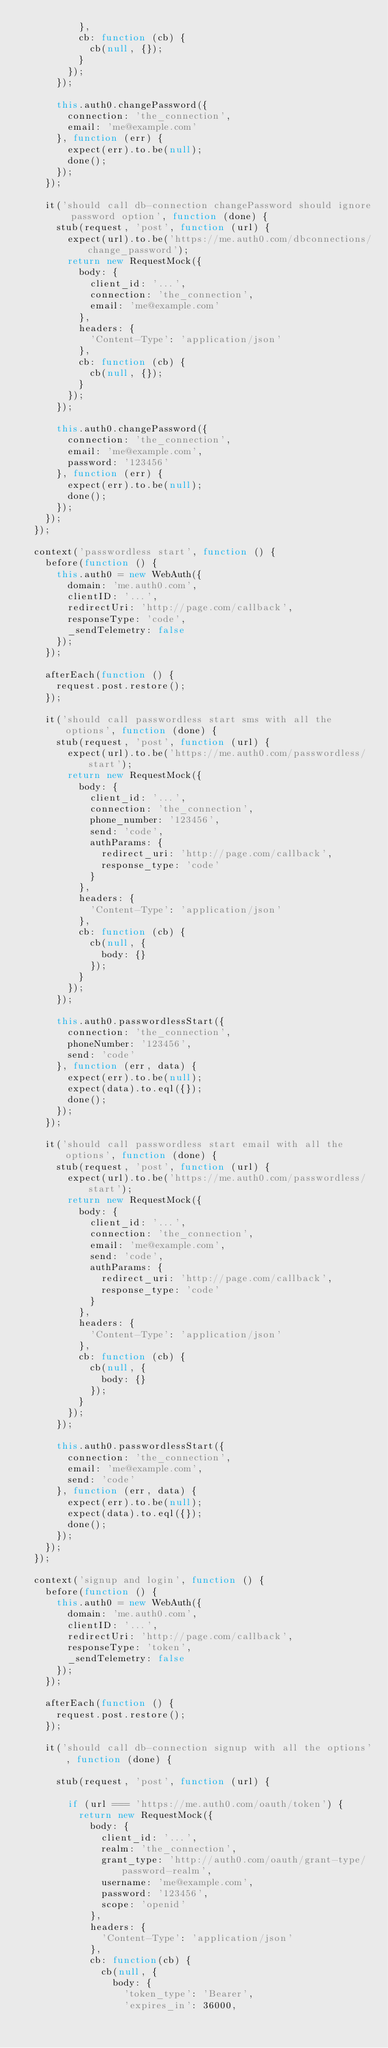Convert code to text. <code><loc_0><loc_0><loc_500><loc_500><_JavaScript_>          },
          cb: function (cb) {
            cb(null, {});
          }
        });
      });

      this.auth0.changePassword({
        connection: 'the_connection',
        email: 'me@example.com'
      }, function (err) {
        expect(err).to.be(null);
        done();
      });
    });

    it('should call db-connection changePassword should ignore password option', function (done) {
      stub(request, 'post', function (url) {
        expect(url).to.be('https://me.auth0.com/dbconnections/change_password');
        return new RequestMock({
          body: {
            client_id: '...',
            connection: 'the_connection',
            email: 'me@example.com'
          },
          headers: {
            'Content-Type': 'application/json'
          },
          cb: function (cb) {
            cb(null, {});
          }
        });
      });

      this.auth0.changePassword({
        connection: 'the_connection',
        email: 'me@example.com',
        password: '123456'
      }, function (err) {
        expect(err).to.be(null);
        done();
      });
    });
  });

  context('passwordless start', function () {
    before(function () {
      this.auth0 = new WebAuth({
        domain: 'me.auth0.com',
        clientID: '...',
        redirectUri: 'http://page.com/callback',
        responseType: 'code',
        _sendTelemetry: false
      });
    });

    afterEach(function () {
      request.post.restore();
    });

    it('should call passwordless start sms with all the options', function (done) {
      stub(request, 'post', function (url) {
        expect(url).to.be('https://me.auth0.com/passwordless/start');
        return new RequestMock({
          body: {
            client_id: '...',
            connection: 'the_connection',
            phone_number: '123456',
            send: 'code',
            authParams: {
              redirect_uri: 'http://page.com/callback',
              response_type: 'code'
            }
          },
          headers: {
            'Content-Type': 'application/json'
          },
          cb: function (cb) {
            cb(null, {
              body: {}
            });
          }
        });
      });

      this.auth0.passwordlessStart({
        connection: 'the_connection',
        phoneNumber: '123456',
        send: 'code'
      }, function (err, data) {
        expect(err).to.be(null);
        expect(data).to.eql({});
        done();
      });
    });

    it('should call passwordless start email with all the options', function (done) {
      stub(request, 'post', function (url) {
        expect(url).to.be('https://me.auth0.com/passwordless/start');
        return new RequestMock({
          body: {
            client_id: '...',
            connection: 'the_connection',
            email: 'me@example.com',
            send: 'code',
            authParams: {
              redirect_uri: 'http://page.com/callback',
              response_type: 'code'
            }
          },
          headers: {
            'Content-Type': 'application/json'
          },
          cb: function (cb) {
            cb(null, {
              body: {}
            });
          }
        });
      });

      this.auth0.passwordlessStart({
        connection: 'the_connection',
        email: 'me@example.com',
        send: 'code'
      }, function (err, data) {
        expect(err).to.be(null);
        expect(data).to.eql({});
        done();
      });
    });
  });

  context('signup and login', function () {
    before(function () {
      this.auth0 = new WebAuth({
        domain: 'me.auth0.com',
        clientID: '...',
        redirectUri: 'http://page.com/callback',
        responseType: 'token',
        _sendTelemetry: false
      });
    });

    afterEach(function () {
      request.post.restore();
    });

    it('should call db-connection signup with all the options', function (done) {

      stub(request, 'post', function (url) {

        if (url === 'https://me.auth0.com/oauth/token') {
          return new RequestMock({
            body: {
              client_id: '...',
              realm: 'the_connection',
              grant_type: 'http://auth0.com/oauth/grant-type/password-realm',
              username: 'me@example.com',
              password: '123456',
              scope: 'openid'
            },
            headers: {
              'Content-Type': 'application/json'
            },
            cb: function(cb) {
              cb(null, {
                body: {
                  'token_type': 'Bearer',
                  'expires_in': 36000,</code> 